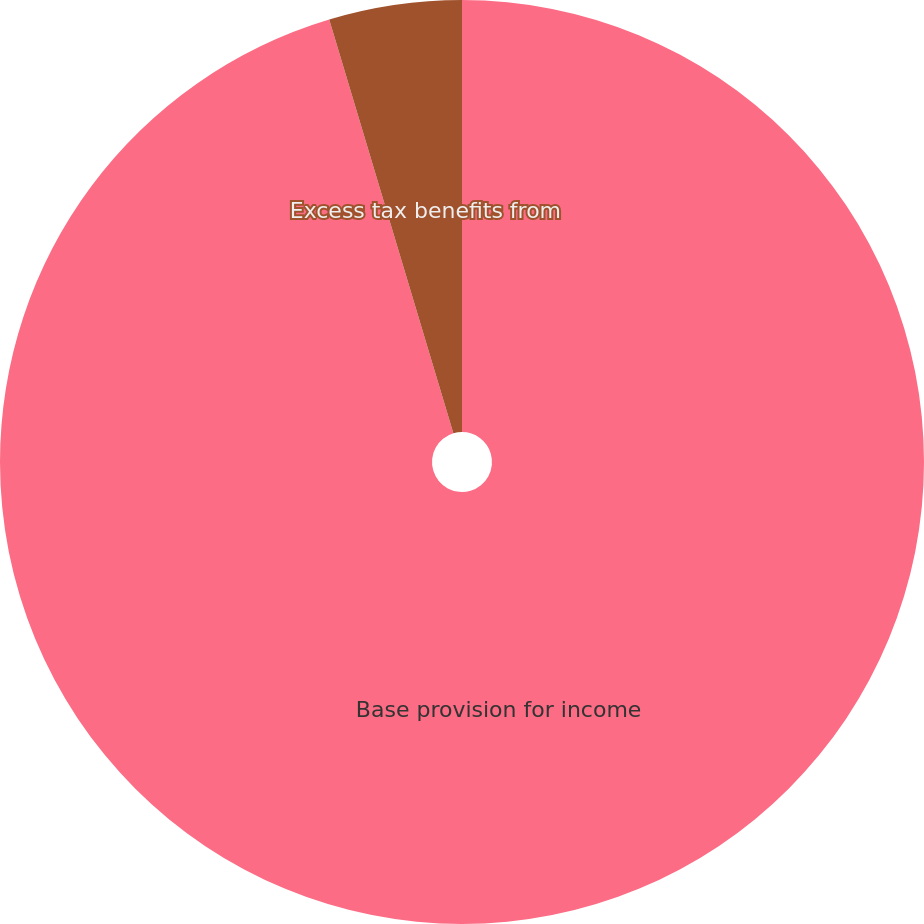<chart> <loc_0><loc_0><loc_500><loc_500><pie_chart><fcel>Base provision for income<fcel>Excess tax benefits from<nl><fcel>95.36%<fcel>4.64%<nl></chart> 